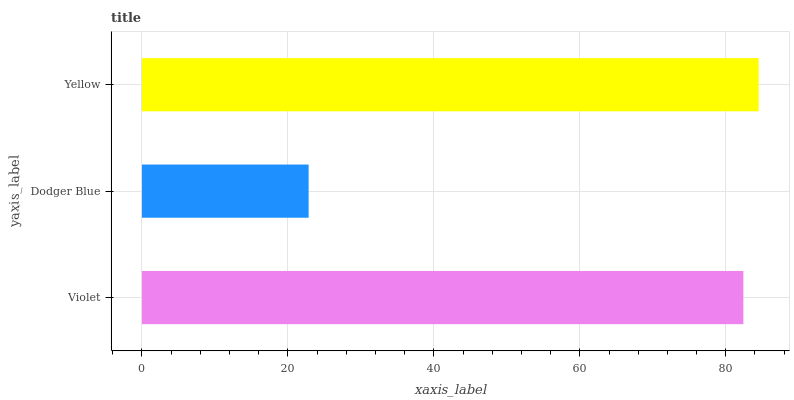Is Dodger Blue the minimum?
Answer yes or no. Yes. Is Yellow the maximum?
Answer yes or no. Yes. Is Yellow the minimum?
Answer yes or no. No. Is Dodger Blue the maximum?
Answer yes or no. No. Is Yellow greater than Dodger Blue?
Answer yes or no. Yes. Is Dodger Blue less than Yellow?
Answer yes or no. Yes. Is Dodger Blue greater than Yellow?
Answer yes or no. No. Is Yellow less than Dodger Blue?
Answer yes or no. No. Is Violet the high median?
Answer yes or no. Yes. Is Violet the low median?
Answer yes or no. Yes. Is Dodger Blue the high median?
Answer yes or no. No. Is Yellow the low median?
Answer yes or no. No. 